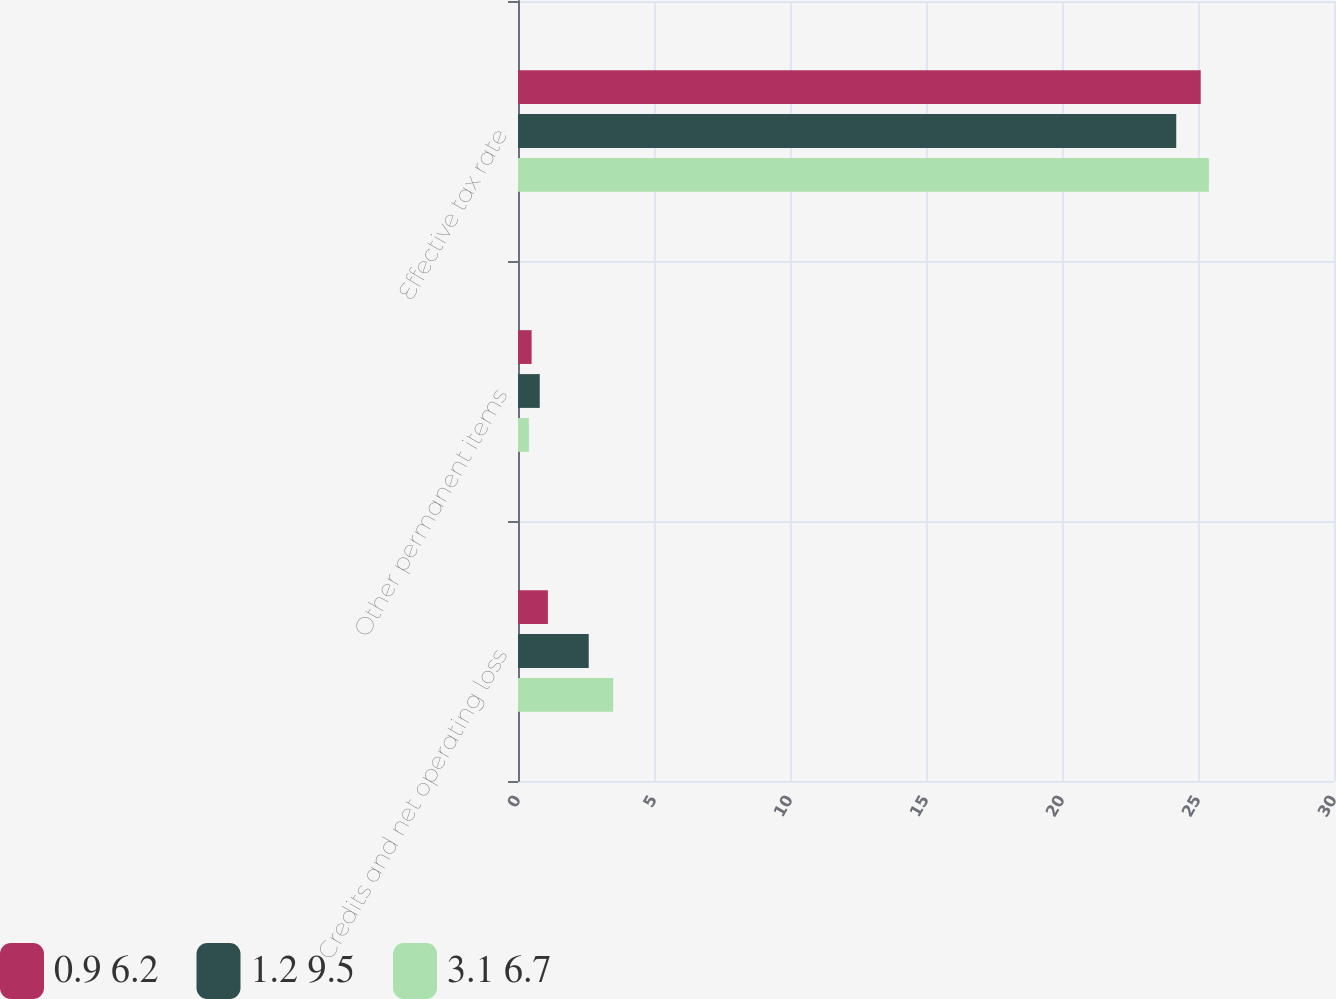<chart> <loc_0><loc_0><loc_500><loc_500><stacked_bar_chart><ecel><fcel>Credits and net operating loss<fcel>Other permanent items<fcel>Effective tax rate<nl><fcel>0.9 6.2<fcel>1.1<fcel>0.5<fcel>25.1<nl><fcel>1.2 9.5<fcel>2.6<fcel>0.8<fcel>24.2<nl><fcel>3.1 6.7<fcel>3.5<fcel>0.4<fcel>25.4<nl></chart> 